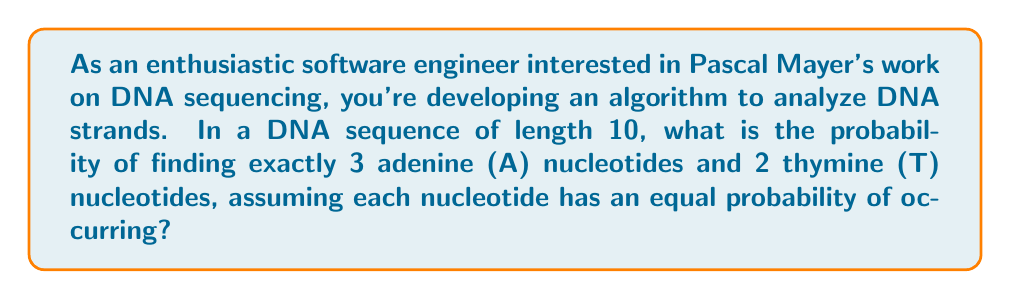Show me your answer to this math problem. Let's approach this step-by-step:

1) First, recall that DNA has four types of nucleotides: Adenine (A), Thymine (T), Cytosine (C), and Guanine (G).

2) We're dealing with a sequence of 10 nucleotides, and we need to calculate the probability of having exactly 3 A's and 2 T's.

3) This is a combination problem. We need to:
   a) Choose the positions for the 3 A's and 2 T's
   b) Calculate the probability of this specific arrangement

4) To choose the positions:
   - We need to choose 3 positions out of 10 for A: $\binom{10}{3}$
   - From the remaining 7 positions, we need to choose 2 for T: $\binom{7}{2}$

5) The number of ways to arrange 3 A's and 2 T's in a sequence of 10 is:

   $$\binom{10}{3} \cdot \binom{7}{2}$$

6) Now, for the probability:
   - Each nucleotide has a 1/4 probability of occurring
   - We need (1/4)^3 for the 3 A's
   - (1/4)^2 for the 2 T's
   - (1/4)^5 for the remaining 5 positions (which can be C or G)

7) Therefore, the probability of one specific arrangement is:

   $$(\frac{1}{4})^3 \cdot (\frac{1}{4})^2 \cdot (\frac{1}{4})^5 = (\frac{1}{4})^{10}$$

8) Combining steps 5 and 7, the total probability is:

   $$\binom{10}{3} \cdot \binom{7}{2} \cdot (\frac{1}{4})^{10}$$

9) Let's calculate:
   $\binom{10}{3} = 120$
   $\binom{7}{2} = 21$
   $120 \cdot 21 = 2520$
   $(\frac{1}{4})^{10} = \frac{1}{1,048,576}$

10) Final calculation:
    $$2520 \cdot \frac{1}{1,048,576} = \frac{2520}{1,048,576} = \frac{5}{2048} \approx 0.00244$$
Answer: The probability is $\frac{5}{2048}$ or approximately 0.00244 (0.244%) 